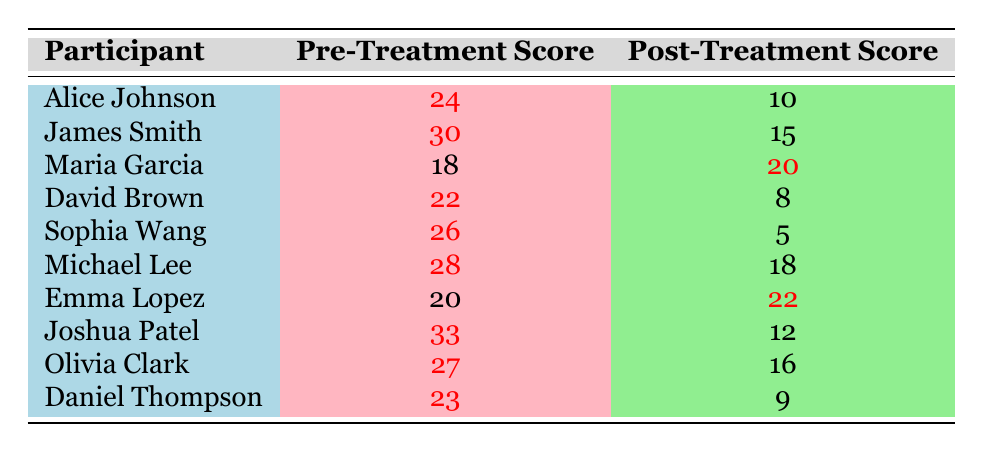What was the lowest post-treatment score? Looking at the post-treatment scores in the table, the lowest score is 5, attributed to Sophia Wang.
Answer: 5 Which participant had the highest pre-treatment score? By checking the pre-treatment scores, Joshua Patel has the highest score at 33.
Answer: Joshua Patel What is the average pre-treatment score of all participants? The sum of pre-treatment scores is (24 + 30 + 18 + 22 + 26 + 28 + 20 + 33 + 27 + 23) =  258. There are 10 participants, so the average is 258/10 = 25.8.
Answer: 25.8 Did any participant show an increase in their depression score from pre-treatment to post-treatment? Yes, Emma Lopez had a pre-treatment score of 20 and a post-treatment score of 22, indicating an increase.
Answer: Yes Who had the largest decrease in depression score after treatment? Calculating the difference in scores for each participant: Alice Johnson (14), James Smith (15), David Brown (14), Sophia Wang (21), Michael Lee (10), Joshua Patel (21), Olivia Clark (11), Daniel Thompson (14). The largest decrease was for Sophia Wang, who decreased by 21 points.
Answer: Sophia Wang What is the total combined decrease in scores for Alice Johnson and David Brown? The decreases for Alice Johnson and David Brown are 14 and 14, respectively. Adding these gives a total decrease of 14 + 14 = 28.
Answer: 28 How many participants had post-treatment scores below the average of the pre-treatment scores? The average pre-treatment score is 25.8. The participants with post-treatment scores below this average are Maria Garcia (20), David Brown (8), Sophia Wang (5), Michael Lee (18), Joshua Patel (12), and Daniel Thompson (9) - a total of 6 participants.
Answer: 6 Was there a participant whose post-treatment score was the same as their pre-treatment score? No, all participants had different pre- and post-treatment scores.
Answer: No What percentage of participants decreased their scores from pre-treatment to post-treatment? Out of the 10 participants, 6 showed a decrease. Therefore, the percentage is (6/10) * 100 = 60%.
Answer: 60% Who had the second highest pre-treatment score? The highest pre-treatment score belongs to Joshua Patel (33), followed by James Smith (30) as the second highest.
Answer: James Smith 